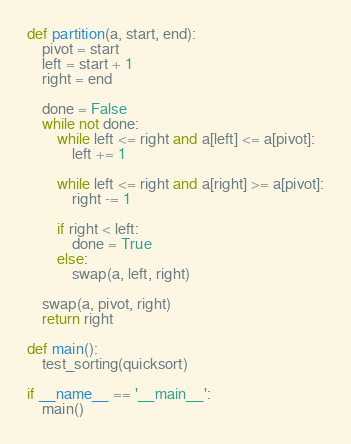Convert code to text. <code><loc_0><loc_0><loc_500><loc_500><_Python_>def partition(a, start, end):
    pivot = start
    left = start + 1
    right = end
   
    done = False
    while not done:
        while left <= right and a[left] <= a[pivot]:
            left += 1

        while left <= right and a[right] >= a[pivot]:
            right -= 1

        if right < left:
            done = True
        else:
            swap(a, left, right)
    
    swap(a, pivot, right)
    return right

def main():
    test_sorting(quicksort)

if __name__ == '__main__':
    main()
</code> 